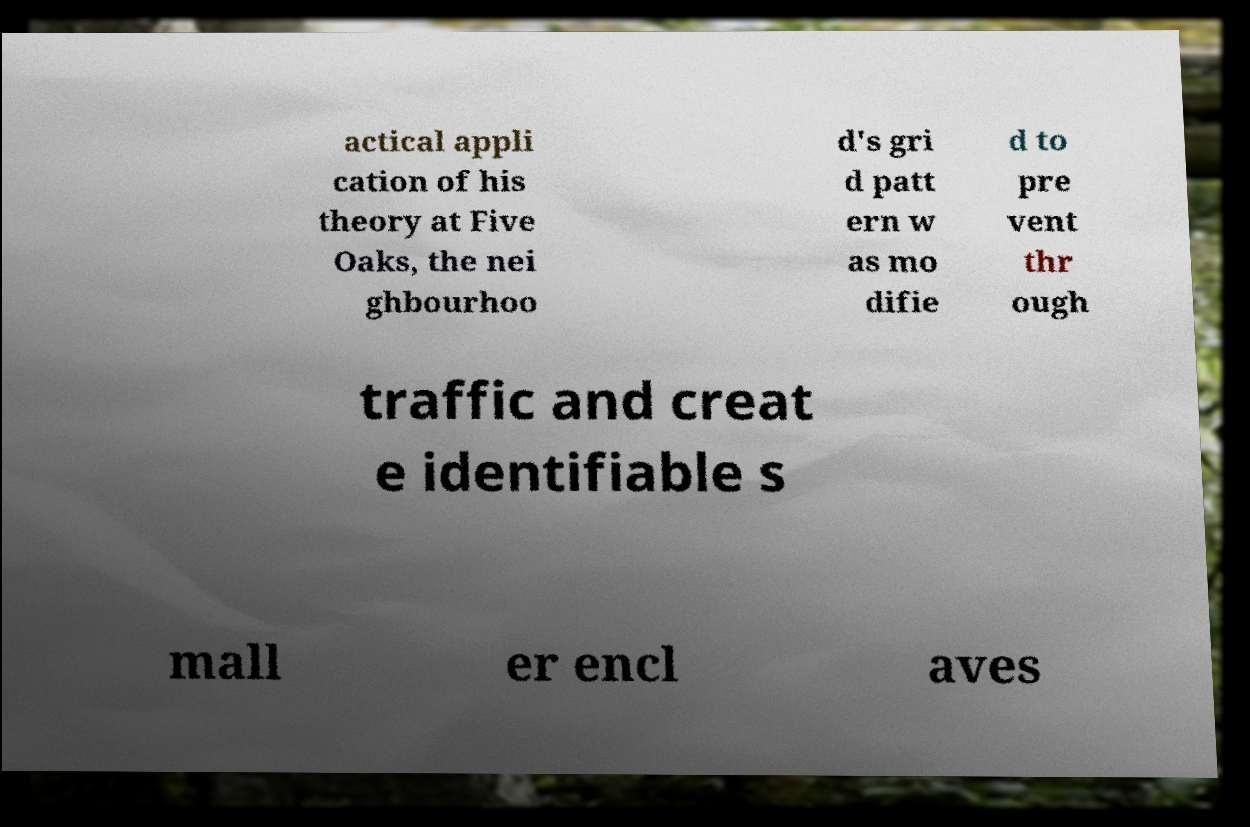Can you read and provide the text displayed in the image?This photo seems to have some interesting text. Can you extract and type it out for me? actical appli cation of his theory at Five Oaks, the nei ghbourhoo d's gri d patt ern w as mo difie d to pre vent thr ough traffic and creat e identifiable s mall er encl aves 